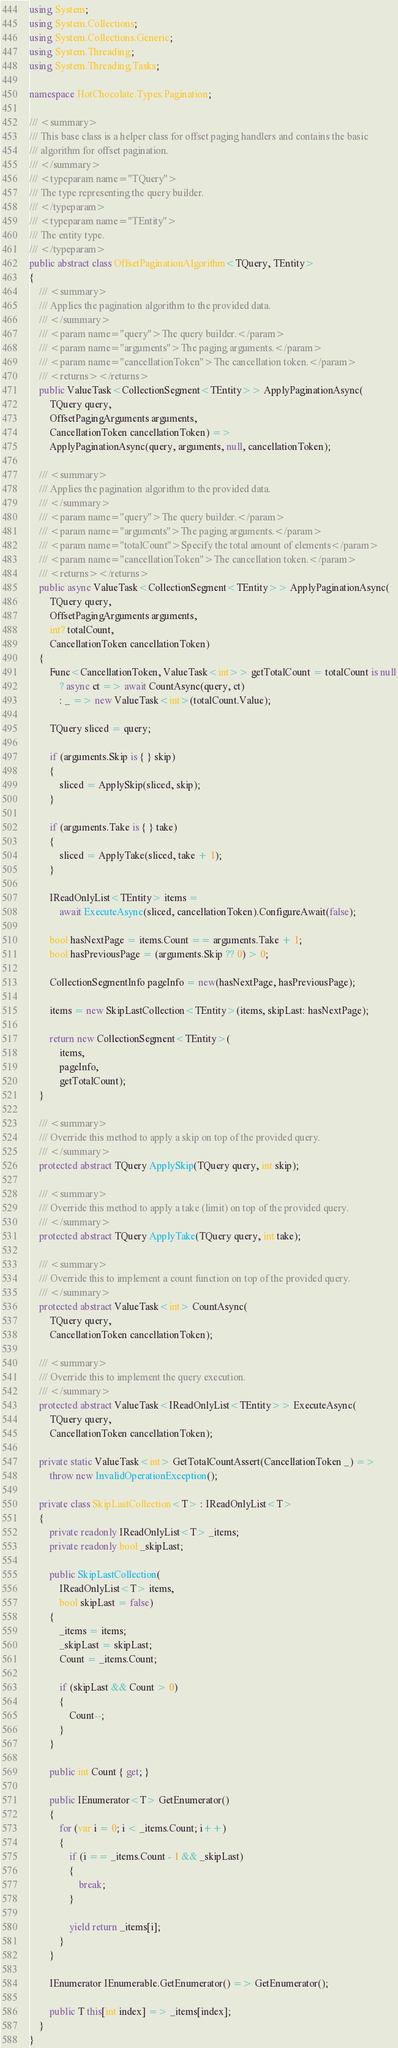Convert code to text. <code><loc_0><loc_0><loc_500><loc_500><_C#_>using System;
using System.Collections;
using System.Collections.Generic;
using System.Threading;
using System.Threading.Tasks;

namespace HotChocolate.Types.Pagination;

/// <summary>
/// This base class is a helper class for offset paging handlers and contains the basic
/// algorithm for offset pagination.
/// </summary>
/// <typeparam name="TQuery">
/// The type representing the query builder.
/// </typeparam>
/// <typeparam name="TEntity">
/// The entity type.
/// </typeparam>
public abstract class OffsetPaginationAlgorithm<TQuery, TEntity>
{
    /// <summary>
    /// Applies the pagination algorithm to the provided data.
    /// </summary>
    /// <param name="query">The query builder.</param>
    /// <param name="arguments">The paging arguments.</param>
    /// <param name="cancellationToken">The cancellation token.</param>
    /// <returns></returns>
    public ValueTask<CollectionSegment<TEntity>> ApplyPaginationAsync(
        TQuery query,
        OffsetPagingArguments arguments,
        CancellationToken cancellationToken) =>
        ApplyPaginationAsync(query, arguments, null, cancellationToken);

    /// <summary>
    /// Applies the pagination algorithm to the provided data.
    /// </summary>
    /// <param name="query">The query builder.</param>
    /// <param name="arguments">The paging arguments.</param>
    /// <param name="totalCount">Specify the total amount of elements</param>
    /// <param name="cancellationToken">The cancellation token.</param>
    /// <returns></returns>
    public async ValueTask<CollectionSegment<TEntity>> ApplyPaginationAsync(
        TQuery query,
        OffsetPagingArguments arguments,
        int? totalCount,
        CancellationToken cancellationToken)
    {
        Func<CancellationToken, ValueTask<int>> getTotalCount = totalCount is null
            ? async ct => await CountAsync(query, ct)
            : _ => new ValueTask<int>(totalCount.Value);

        TQuery sliced = query;

        if (arguments.Skip is { } skip)
        {
            sliced = ApplySkip(sliced, skip);
        }

        if (arguments.Take is { } take)
        {
            sliced = ApplyTake(sliced, take + 1);
        }

        IReadOnlyList<TEntity> items =
            await ExecuteAsync(sliced, cancellationToken).ConfigureAwait(false);

        bool hasNextPage = items.Count == arguments.Take + 1;
        bool hasPreviousPage = (arguments.Skip ?? 0) > 0;

        CollectionSegmentInfo pageInfo = new(hasNextPage, hasPreviousPage);

        items = new SkipLastCollection<TEntity>(items, skipLast: hasNextPage);

        return new CollectionSegment<TEntity>(
            items,
            pageInfo,
            getTotalCount);
    }

    /// <summary>
    /// Override this method to apply a skip on top of the provided query.
    /// </summary>
    protected abstract TQuery ApplySkip(TQuery query, int skip);

    /// <summary>
    /// Override this method to apply a take (limit) on top of the provided query.
    /// </summary>
    protected abstract TQuery ApplyTake(TQuery query, int take);

    /// <summary>
    /// Override this to implement a count function on top of the provided query.
    /// </summary>
    protected abstract ValueTask<int> CountAsync(
        TQuery query,
        CancellationToken cancellationToken);

    /// <summary>
    /// Override this to implement the query execution.
    /// </summary>
    protected abstract ValueTask<IReadOnlyList<TEntity>> ExecuteAsync(
        TQuery query,
        CancellationToken cancellationToken);

    private static ValueTask<int> GetTotalCountAssert(CancellationToken _) =>
        throw new InvalidOperationException();

    private class SkipLastCollection<T> : IReadOnlyList<T>
    {
        private readonly IReadOnlyList<T> _items;
        private readonly bool _skipLast;

        public SkipLastCollection(
            IReadOnlyList<T> items,
            bool skipLast = false)
        {
            _items = items;
            _skipLast = skipLast;
            Count = _items.Count;

            if (skipLast && Count > 0)
            {
                Count--;
            }
        }

        public int Count { get; }

        public IEnumerator<T> GetEnumerator()
        {
            for (var i = 0; i < _items.Count; i++)
            {
                if (i == _items.Count - 1 && _skipLast)
                {
                    break;
                }

                yield return _items[i];
            }
        }

        IEnumerator IEnumerable.GetEnumerator() => GetEnumerator();

        public T this[int index] => _items[index];
    }
}
</code> 